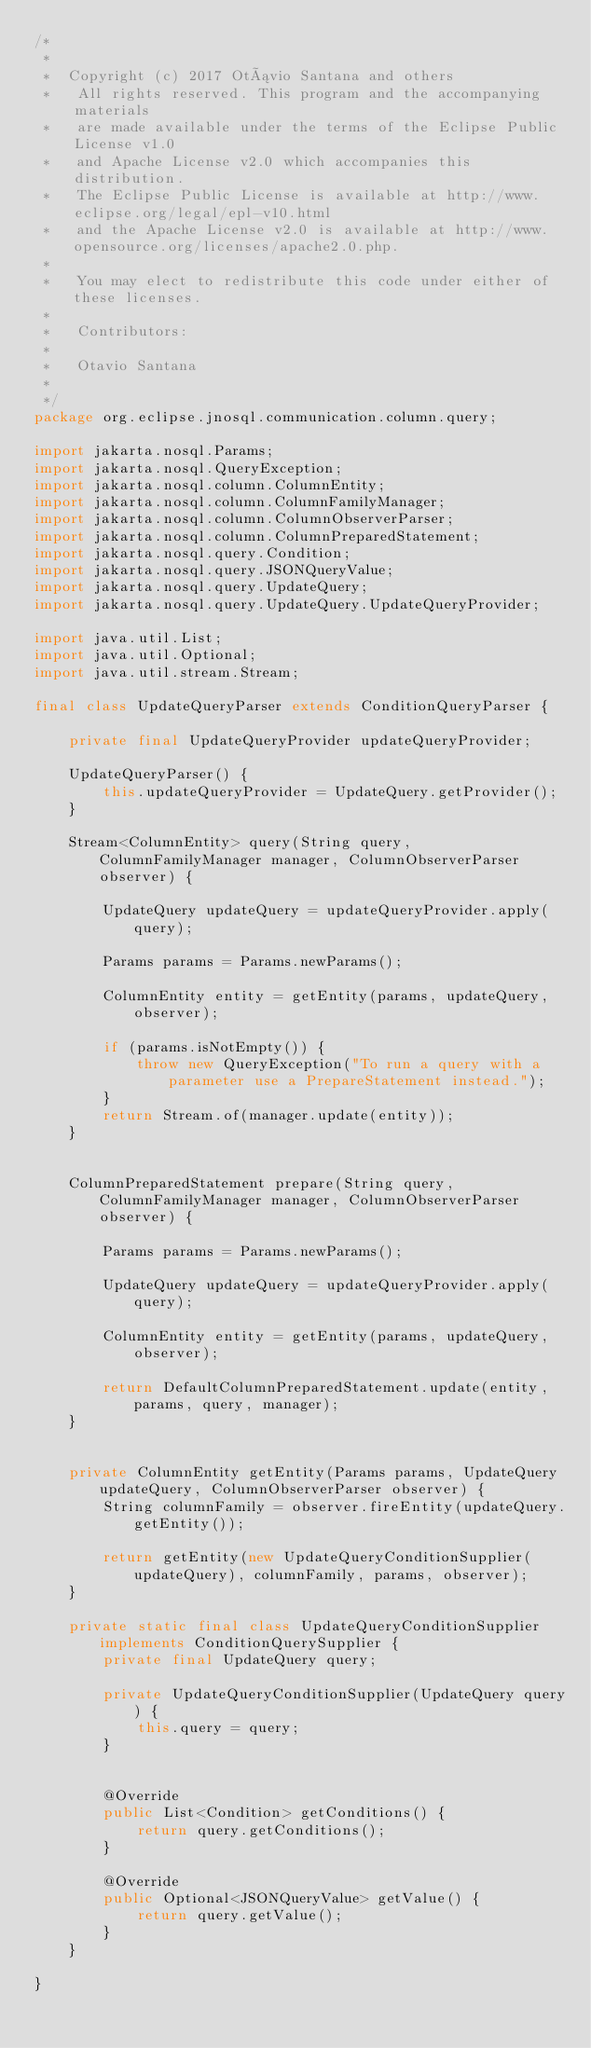Convert code to text. <code><loc_0><loc_0><loc_500><loc_500><_Java_>/*
 *
 *  Copyright (c) 2017 Otávio Santana and others
 *   All rights reserved. This program and the accompanying materials
 *   are made available under the terms of the Eclipse Public License v1.0
 *   and Apache License v2.0 which accompanies this distribution.
 *   The Eclipse Public License is available at http://www.eclipse.org/legal/epl-v10.html
 *   and the Apache License v2.0 is available at http://www.opensource.org/licenses/apache2.0.php.
 *
 *   You may elect to redistribute this code under either of these licenses.
 *
 *   Contributors:
 *
 *   Otavio Santana
 *
 */
package org.eclipse.jnosql.communication.column.query;

import jakarta.nosql.Params;
import jakarta.nosql.QueryException;
import jakarta.nosql.column.ColumnEntity;
import jakarta.nosql.column.ColumnFamilyManager;
import jakarta.nosql.column.ColumnObserverParser;
import jakarta.nosql.column.ColumnPreparedStatement;
import jakarta.nosql.query.Condition;
import jakarta.nosql.query.JSONQueryValue;
import jakarta.nosql.query.UpdateQuery;
import jakarta.nosql.query.UpdateQuery.UpdateQueryProvider;

import java.util.List;
import java.util.Optional;
import java.util.stream.Stream;

final class UpdateQueryParser extends ConditionQueryParser {

    private final UpdateQueryProvider updateQueryProvider;

    UpdateQueryParser() {
        this.updateQueryProvider = UpdateQuery.getProvider();
    }

    Stream<ColumnEntity> query(String query, ColumnFamilyManager manager, ColumnObserverParser observer) {

        UpdateQuery updateQuery = updateQueryProvider.apply(query);

        Params params = Params.newParams();

        ColumnEntity entity = getEntity(params, updateQuery, observer);

        if (params.isNotEmpty()) {
            throw new QueryException("To run a query with a parameter use a PrepareStatement instead.");
        }
        return Stream.of(manager.update(entity));
    }


    ColumnPreparedStatement prepare(String query, ColumnFamilyManager manager, ColumnObserverParser observer) {

        Params params = Params.newParams();

        UpdateQuery updateQuery = updateQueryProvider.apply(query);

        ColumnEntity entity = getEntity(params, updateQuery, observer);

        return DefaultColumnPreparedStatement.update(entity, params, query, manager);
    }


    private ColumnEntity getEntity(Params params, UpdateQuery updateQuery, ColumnObserverParser observer) {
        String columnFamily = observer.fireEntity(updateQuery.getEntity());

        return getEntity(new UpdateQueryConditionSupplier(updateQuery), columnFamily, params, observer);
    }

    private static final class UpdateQueryConditionSupplier implements ConditionQuerySupplier {
        private final UpdateQuery query;

        private UpdateQueryConditionSupplier(UpdateQuery query) {
            this.query = query;
        }


        @Override
        public List<Condition> getConditions() {
            return query.getConditions();
        }

        @Override
        public Optional<JSONQueryValue> getValue() {
            return query.getValue();
        }
    }

}</code> 